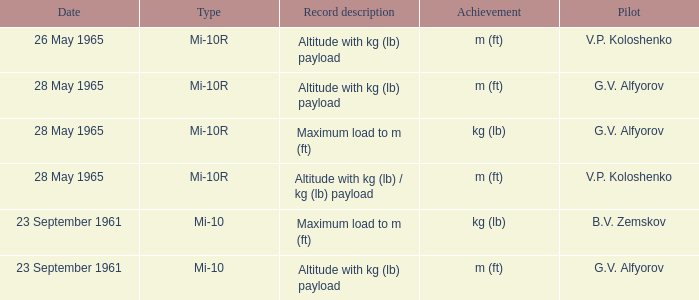Date of 23 september 1961, and a Pilot of b.v. zemskov had what record description? Maximum load to m (ft). 